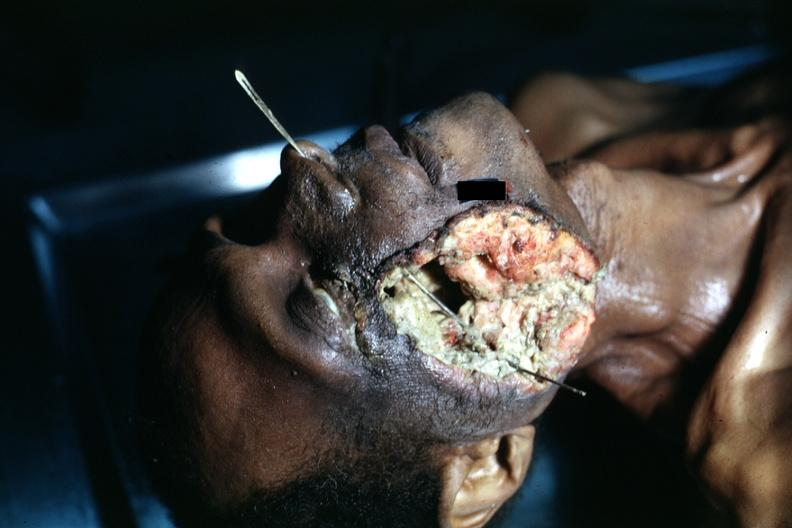what does this image show?
Answer the question using a single word or phrase. View of head with huge ulcerated mass where tumor grew to outside 